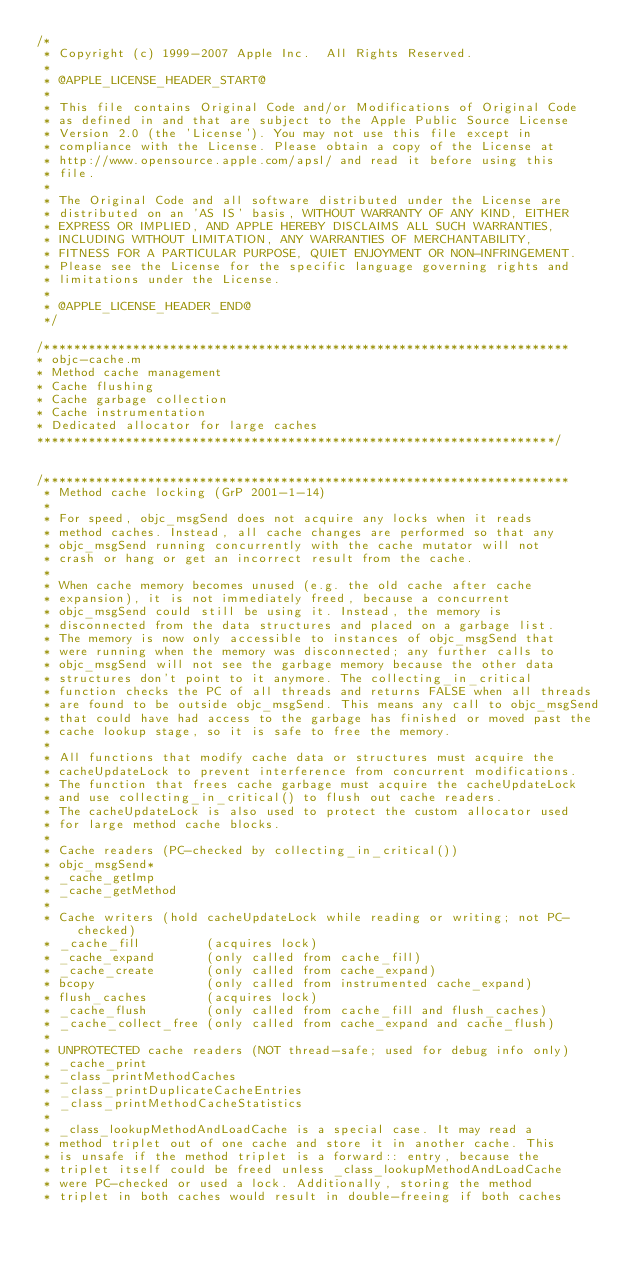Convert code to text. <code><loc_0><loc_0><loc_500><loc_500><_ObjectiveC_>/*
 * Copyright (c) 1999-2007 Apple Inc.  All Rights Reserved.
 * 
 * @APPLE_LICENSE_HEADER_START@
 * 
 * This file contains Original Code and/or Modifications of Original Code
 * as defined in and that are subject to the Apple Public Source License
 * Version 2.0 (the 'License'). You may not use this file except in
 * compliance with the License. Please obtain a copy of the License at
 * http://www.opensource.apple.com/apsl/ and read it before using this
 * file.
 * 
 * The Original Code and all software distributed under the License are
 * distributed on an 'AS IS' basis, WITHOUT WARRANTY OF ANY KIND, EITHER
 * EXPRESS OR IMPLIED, AND APPLE HEREBY DISCLAIMS ALL SUCH WARRANTIES,
 * INCLUDING WITHOUT LIMITATION, ANY WARRANTIES OF MERCHANTABILITY,
 * FITNESS FOR A PARTICULAR PURPOSE, QUIET ENJOYMENT OR NON-INFRINGEMENT.
 * Please see the License for the specific language governing rights and
 * limitations under the License.
 * 
 * @APPLE_LICENSE_HEADER_END@
 */

/***********************************************************************
* objc-cache.m
* Method cache management
* Cache flushing
* Cache garbage collection
* Cache instrumentation
* Dedicated allocator for large caches
**********************************************************************/


/***********************************************************************
 * Method cache locking (GrP 2001-1-14)
 *
 * For speed, objc_msgSend does not acquire any locks when it reads 
 * method caches. Instead, all cache changes are performed so that any 
 * objc_msgSend running concurrently with the cache mutator will not 
 * crash or hang or get an incorrect result from the cache. 
 *
 * When cache memory becomes unused (e.g. the old cache after cache 
 * expansion), it is not immediately freed, because a concurrent 
 * objc_msgSend could still be using it. Instead, the memory is 
 * disconnected from the data structures and placed on a garbage list. 
 * The memory is now only accessible to instances of objc_msgSend that 
 * were running when the memory was disconnected; any further calls to 
 * objc_msgSend will not see the garbage memory because the other data 
 * structures don't point to it anymore. The collecting_in_critical
 * function checks the PC of all threads and returns FALSE when all threads 
 * are found to be outside objc_msgSend. This means any call to objc_msgSend 
 * that could have had access to the garbage has finished or moved past the 
 * cache lookup stage, so it is safe to free the memory.
 *
 * All functions that modify cache data or structures must acquire the 
 * cacheUpdateLock to prevent interference from concurrent modifications.
 * The function that frees cache garbage must acquire the cacheUpdateLock 
 * and use collecting_in_critical() to flush out cache readers.
 * The cacheUpdateLock is also used to protect the custom allocator used 
 * for large method cache blocks.
 *
 * Cache readers (PC-checked by collecting_in_critical())
 * objc_msgSend*
 * _cache_getImp
 * _cache_getMethod
 *
 * Cache writers (hold cacheUpdateLock while reading or writing; not PC-checked)
 * _cache_fill         (acquires lock)
 * _cache_expand       (only called from cache_fill)
 * _cache_create       (only called from cache_expand)
 * bcopy               (only called from instrumented cache_expand)
 * flush_caches        (acquires lock)
 * _cache_flush        (only called from cache_fill and flush_caches)
 * _cache_collect_free (only called from cache_expand and cache_flush)
 *
 * UNPROTECTED cache readers (NOT thread-safe; used for debug info only)
 * _cache_print
 * _class_printMethodCaches
 * _class_printDuplicateCacheEntries
 * _class_printMethodCacheStatistics
 *
 * _class_lookupMethodAndLoadCache is a special case. It may read a 
 * method triplet out of one cache and store it in another cache. This 
 * is unsafe if the method triplet is a forward:: entry, because the 
 * triplet itself could be freed unless _class_lookupMethodAndLoadCache 
 * were PC-checked or used a lock. Additionally, storing the method 
 * triplet in both caches would result in double-freeing if both caches </code> 